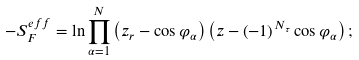Convert formula to latex. <formula><loc_0><loc_0><loc_500><loc_500>- S _ { F } ^ { e f f } = \ln \prod _ { \alpha = 1 } ^ { N } \left ( z _ { r } - \cos \varphi _ { \alpha } \right ) \left ( z - \left ( - 1 \right ) ^ { N _ { \tau } } \cos \varphi _ { \alpha } \right ) ;</formula> 